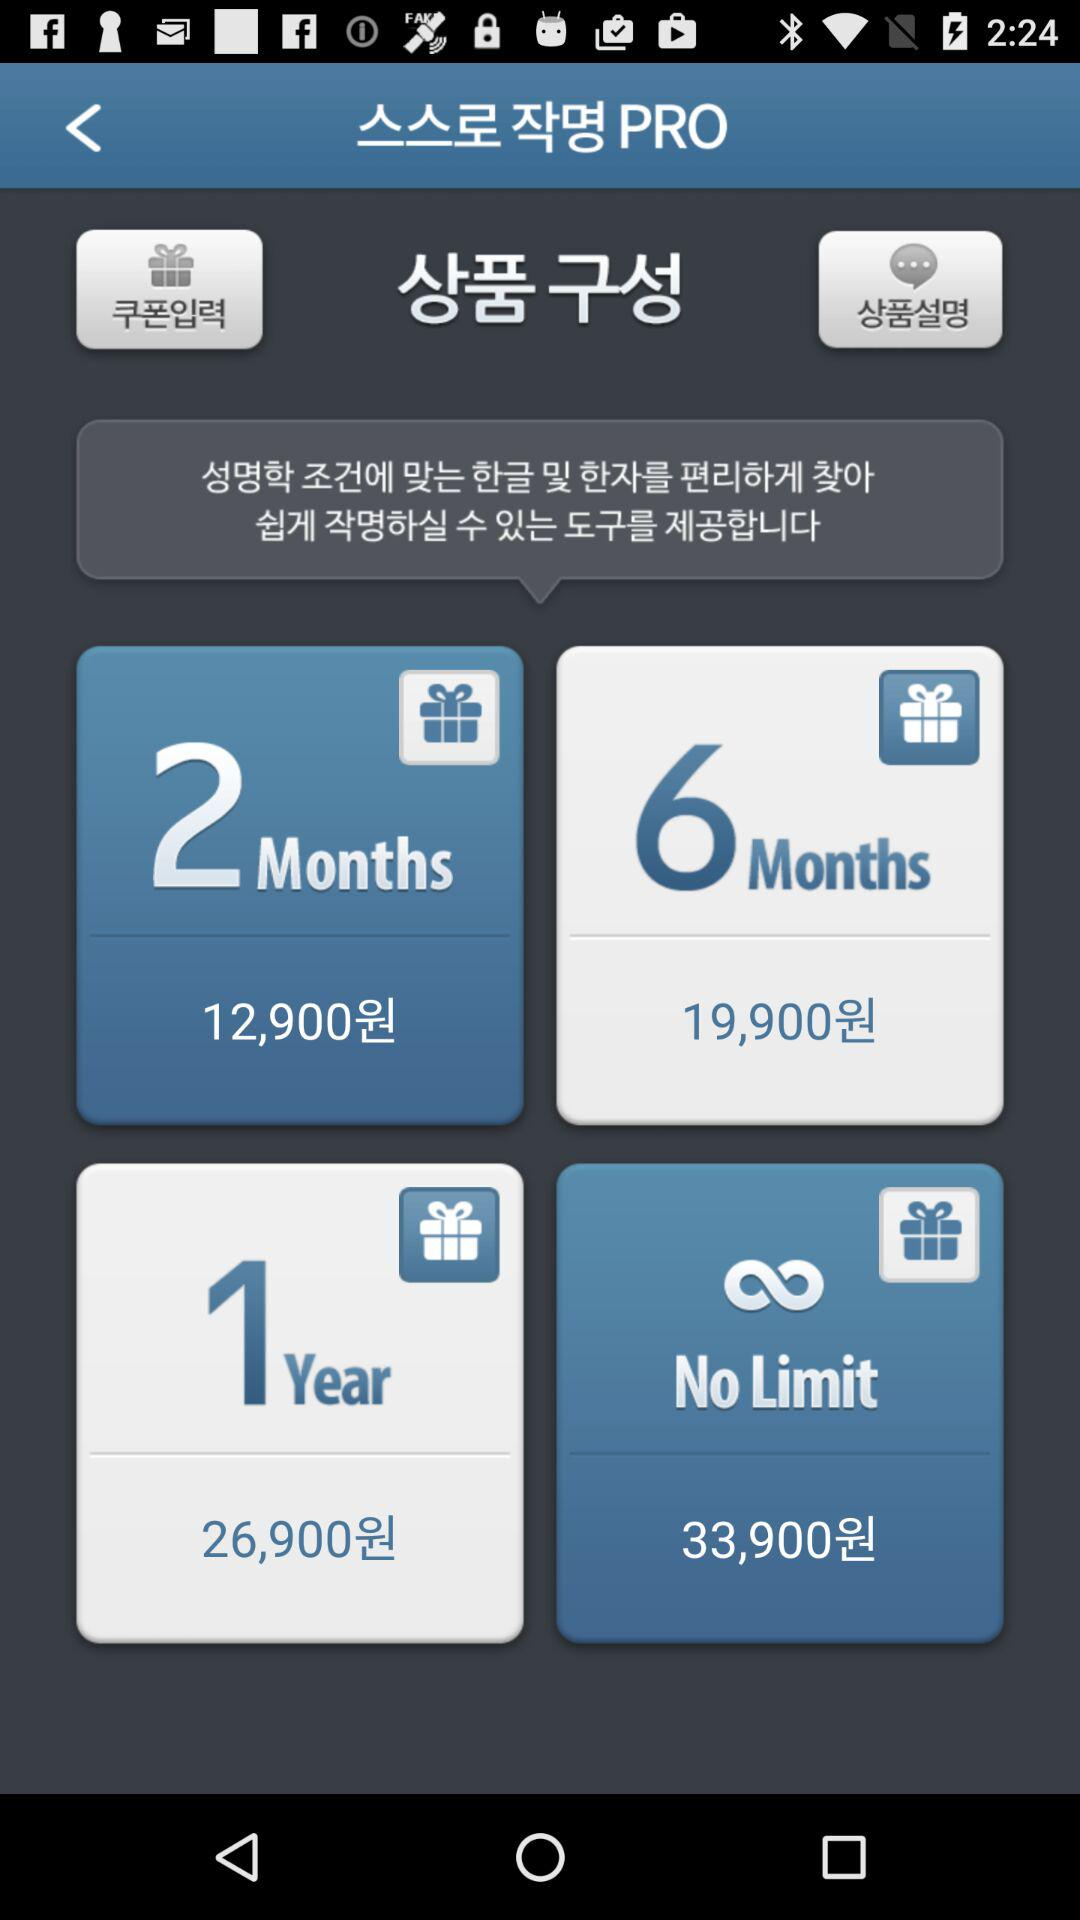How much more does the 1 year plan cost than the 2 month plan?
Answer the question using a single word or phrase. 14000 